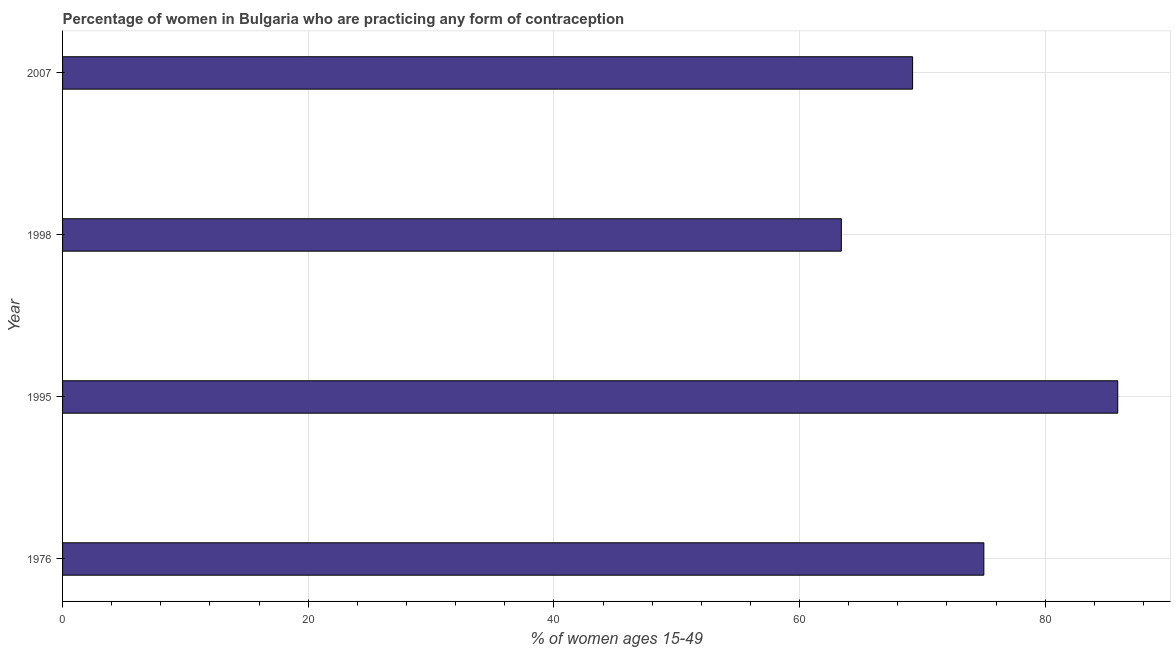Does the graph contain grids?
Provide a succinct answer. Yes. What is the title of the graph?
Provide a short and direct response. Percentage of women in Bulgaria who are practicing any form of contraception. What is the label or title of the X-axis?
Your response must be concise. % of women ages 15-49. What is the contraceptive prevalence in 2007?
Make the answer very short. 69.2. Across all years, what is the maximum contraceptive prevalence?
Your answer should be very brief. 85.9. Across all years, what is the minimum contraceptive prevalence?
Offer a very short reply. 63.4. In which year was the contraceptive prevalence minimum?
Provide a short and direct response. 1998. What is the sum of the contraceptive prevalence?
Offer a very short reply. 293.5. What is the average contraceptive prevalence per year?
Offer a terse response. 73.38. What is the median contraceptive prevalence?
Provide a succinct answer. 72.1. Do a majority of the years between 1976 and 2007 (inclusive) have contraceptive prevalence greater than 48 %?
Your answer should be compact. Yes. What is the ratio of the contraceptive prevalence in 1998 to that in 2007?
Offer a terse response. 0.92. Is the contraceptive prevalence in 1976 less than that in 2007?
Your answer should be compact. No. What is the difference between the highest and the second highest contraceptive prevalence?
Provide a short and direct response. 10.9. What is the difference between the highest and the lowest contraceptive prevalence?
Provide a short and direct response. 22.5. How many bars are there?
Offer a terse response. 4. What is the difference between two consecutive major ticks on the X-axis?
Offer a very short reply. 20. Are the values on the major ticks of X-axis written in scientific E-notation?
Keep it short and to the point. No. What is the % of women ages 15-49 in 1995?
Offer a terse response. 85.9. What is the % of women ages 15-49 of 1998?
Provide a succinct answer. 63.4. What is the % of women ages 15-49 of 2007?
Provide a succinct answer. 69.2. What is the ratio of the % of women ages 15-49 in 1976 to that in 1995?
Keep it short and to the point. 0.87. What is the ratio of the % of women ages 15-49 in 1976 to that in 1998?
Give a very brief answer. 1.18. What is the ratio of the % of women ages 15-49 in 1976 to that in 2007?
Give a very brief answer. 1.08. What is the ratio of the % of women ages 15-49 in 1995 to that in 1998?
Keep it short and to the point. 1.35. What is the ratio of the % of women ages 15-49 in 1995 to that in 2007?
Ensure brevity in your answer.  1.24. What is the ratio of the % of women ages 15-49 in 1998 to that in 2007?
Your answer should be very brief. 0.92. 